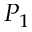Convert formula to latex. <formula><loc_0><loc_0><loc_500><loc_500>P _ { 1 }</formula> 